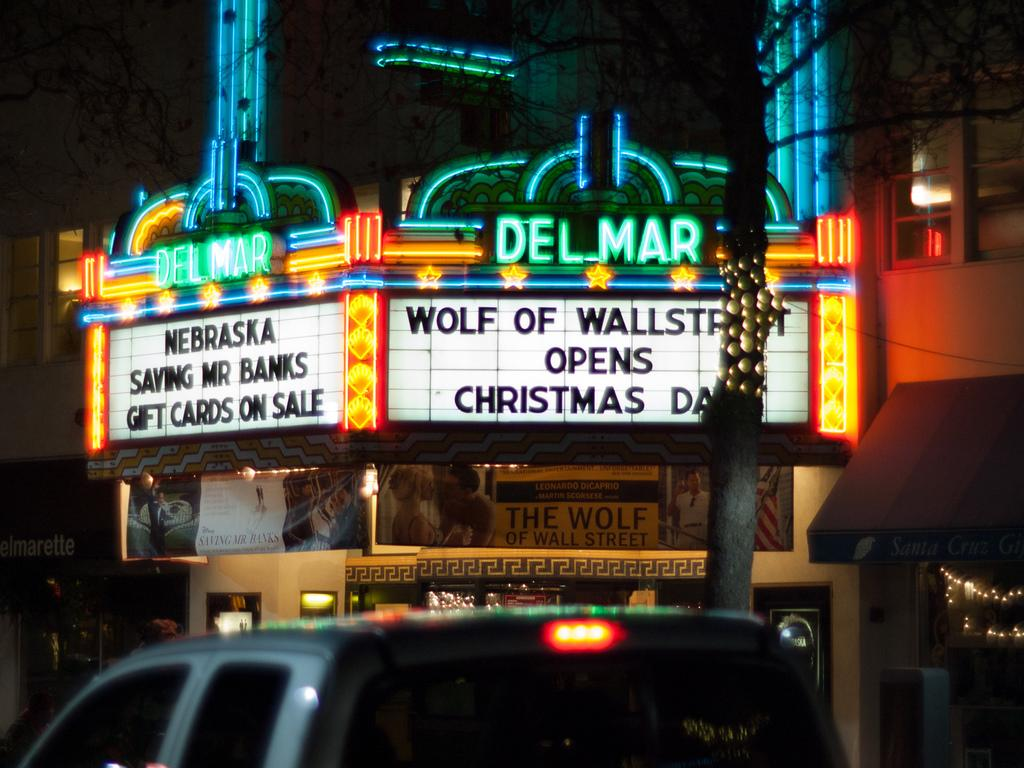Provide a one-sentence caption for the provided image. Two movies are playing at the Del Mar theatre, and another opens on Christmas. 